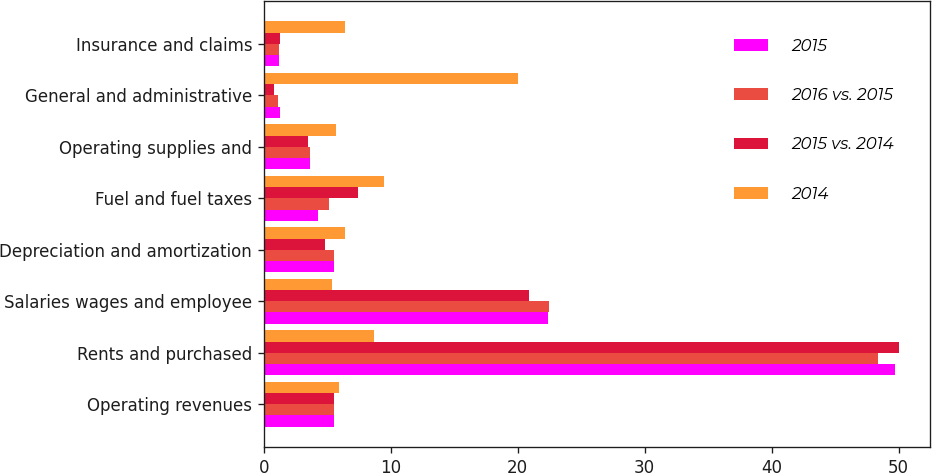<chart> <loc_0><loc_0><loc_500><loc_500><stacked_bar_chart><ecel><fcel>Operating revenues<fcel>Rents and purchased<fcel>Salaries wages and employee<fcel>Depreciation and amortization<fcel>Fuel and fuel taxes<fcel>Operating supplies and<fcel>General and administrative<fcel>Insurance and claims<nl><fcel>2015<fcel>5.5<fcel>49.7<fcel>22.4<fcel>5.5<fcel>4.3<fcel>3.6<fcel>1.3<fcel>1.2<nl><fcel>2016 vs. 2015<fcel>5.5<fcel>48.4<fcel>22.5<fcel>5.5<fcel>5.1<fcel>3.6<fcel>1.1<fcel>1.2<nl><fcel>2015 vs. 2014<fcel>5.5<fcel>50<fcel>20.9<fcel>4.8<fcel>7.4<fcel>3.5<fcel>0.8<fcel>1.3<nl><fcel>2014<fcel>5.9<fcel>8.7<fcel>5.4<fcel>6.4<fcel>9.5<fcel>5.7<fcel>20<fcel>6.4<nl></chart> 